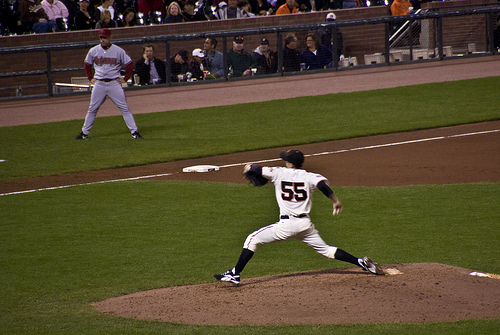On which side of the picture is the coach? The coach is positioned on the left side of the picture, observing the game intently. 